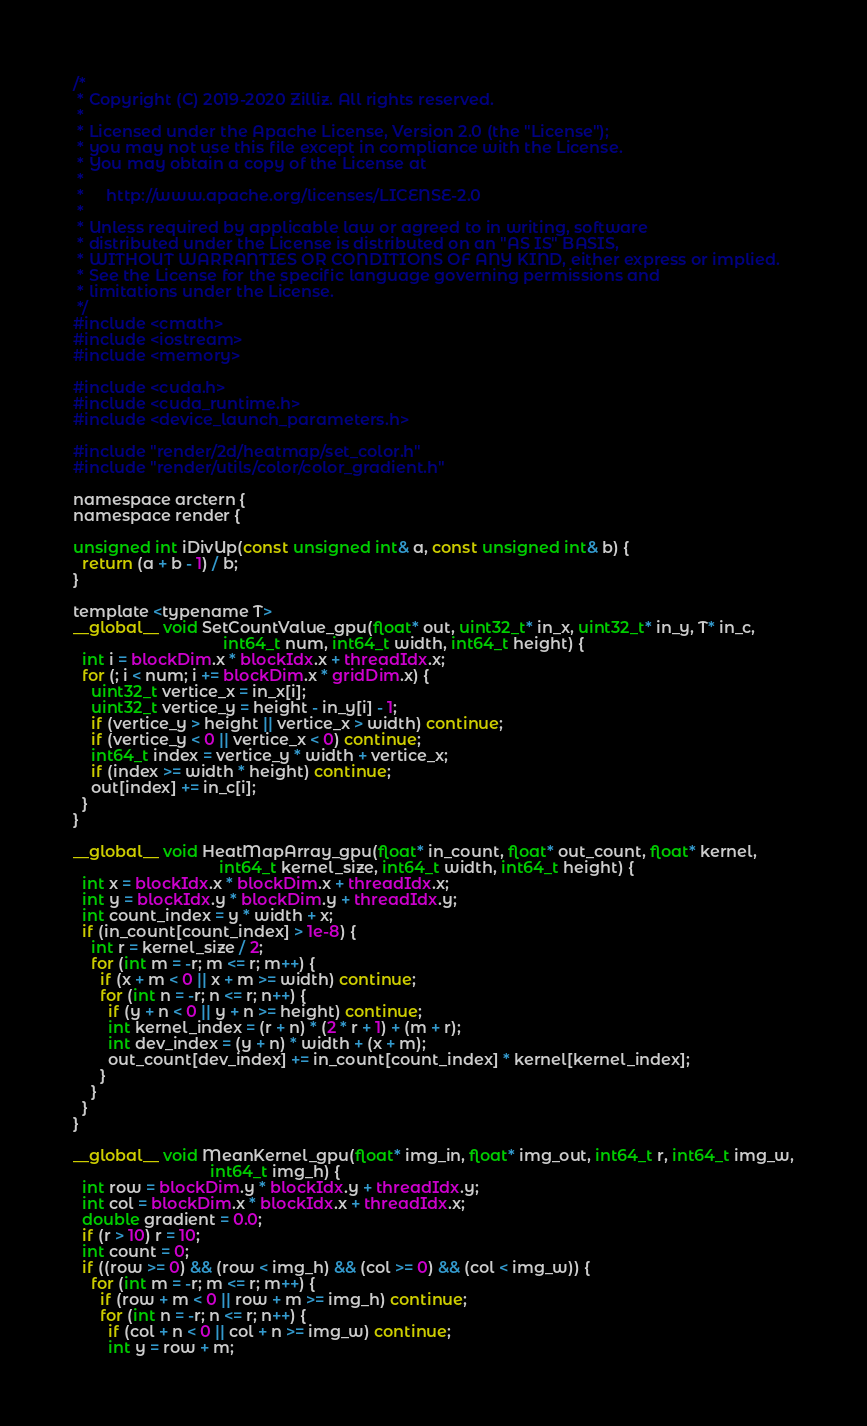<code> <loc_0><loc_0><loc_500><loc_500><_Cuda_>/*
 * Copyright (C) 2019-2020 Zilliz. All rights reserved.
 *
 * Licensed under the Apache License, Version 2.0 (the "License");
 * you may not use this file except in compliance with the License.
 * You may obtain a copy of the License at
 *
 *     http://www.apache.org/licenses/LICENSE-2.0
 *
 * Unless required by applicable law or agreed to in writing, software
 * distributed under the License is distributed on an "AS IS" BASIS,
 * WITHOUT WARRANTIES OR CONDITIONS OF ANY KIND, either express or implied.
 * See the License for the specific language governing permissions and
 * limitations under the License.
 */
#include <cmath>
#include <iostream>
#include <memory>

#include <cuda.h>
#include <cuda_runtime.h>
#include <device_launch_parameters.h>

#include "render/2d/heatmap/set_color.h"
#include "render/utils/color/color_gradient.h"

namespace arctern {
namespace render {

unsigned int iDivUp(const unsigned int& a, const unsigned int& b) {
  return (a + b - 1) / b;
}

template <typename T>
__global__ void SetCountValue_gpu(float* out, uint32_t* in_x, uint32_t* in_y, T* in_c,
                                  int64_t num, int64_t width, int64_t height) {
  int i = blockDim.x * blockIdx.x + threadIdx.x;
  for (; i < num; i += blockDim.x * gridDim.x) {
    uint32_t vertice_x = in_x[i];
    uint32_t vertice_y = height - in_y[i] - 1;
    if (vertice_y > height || vertice_x > width) continue;
    if (vertice_y < 0 || vertice_x < 0) continue;
    int64_t index = vertice_y * width + vertice_x;
    if (index >= width * height) continue;
    out[index] += in_c[i];
  }
}

__global__ void HeatMapArray_gpu(float* in_count, float* out_count, float* kernel,
                                 int64_t kernel_size, int64_t width, int64_t height) {
  int x = blockIdx.x * blockDim.x + threadIdx.x;
  int y = blockIdx.y * blockDim.y + threadIdx.y;
  int count_index = y * width + x;
  if (in_count[count_index] > 1e-8) {
    int r = kernel_size / 2;
    for (int m = -r; m <= r; m++) {
      if (x + m < 0 || x + m >= width) continue;
      for (int n = -r; n <= r; n++) {
        if (y + n < 0 || y + n >= height) continue;
        int kernel_index = (r + n) * (2 * r + 1) + (m + r);
        int dev_index = (y + n) * width + (x + m);
        out_count[dev_index] += in_count[count_index] * kernel[kernel_index];
      }
    }
  }
}

__global__ void MeanKernel_gpu(float* img_in, float* img_out, int64_t r, int64_t img_w,
                               int64_t img_h) {
  int row = blockDim.y * blockIdx.y + threadIdx.y;
  int col = blockDim.x * blockIdx.x + threadIdx.x;
  double gradient = 0.0;
  if (r > 10) r = 10;
  int count = 0;
  if ((row >= 0) && (row < img_h) && (col >= 0) && (col < img_w)) {
    for (int m = -r; m <= r; m++) {
      if (row + m < 0 || row + m >= img_h) continue;
      for (int n = -r; n <= r; n++) {
        if (col + n < 0 || col + n >= img_w) continue;
        int y = row + m;</code> 